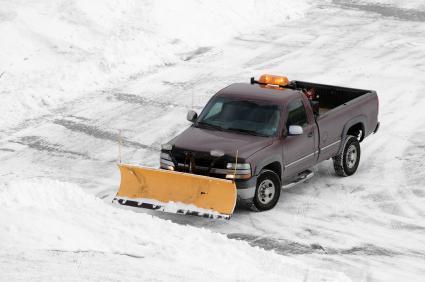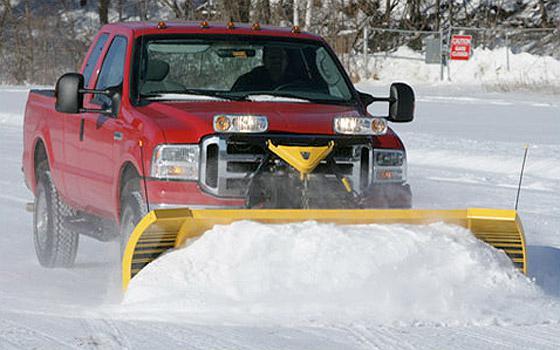The first image is the image on the left, the second image is the image on the right. Assess this claim about the two images: "An image features a truck with an orange cab.". Correct or not? Answer yes or no. No. 